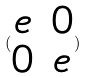Convert formula to latex. <formula><loc_0><loc_0><loc_500><loc_500>( \begin{matrix} e & 0 \\ 0 & e \end{matrix} )</formula> 